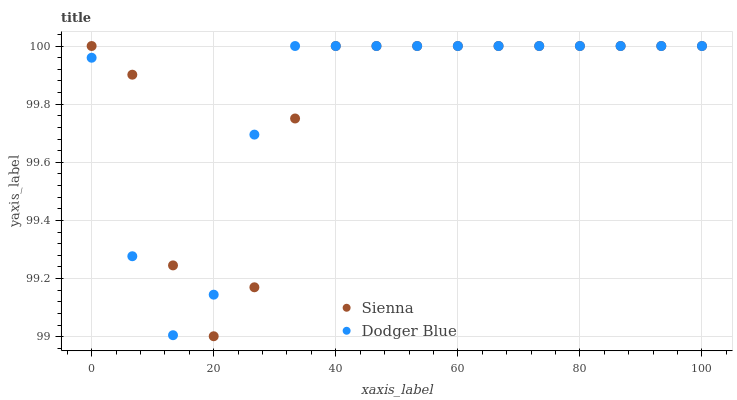Does Sienna have the minimum area under the curve?
Answer yes or no. Yes. Does Dodger Blue have the maximum area under the curve?
Answer yes or no. Yes. Does Dodger Blue have the minimum area under the curve?
Answer yes or no. No. Is Dodger Blue the smoothest?
Answer yes or no. Yes. Is Sienna the roughest?
Answer yes or no. Yes. Is Dodger Blue the roughest?
Answer yes or no. No. Does Sienna have the lowest value?
Answer yes or no. Yes. Does Dodger Blue have the lowest value?
Answer yes or no. No. Does Dodger Blue have the highest value?
Answer yes or no. Yes. Does Sienna intersect Dodger Blue?
Answer yes or no. Yes. Is Sienna less than Dodger Blue?
Answer yes or no. No. Is Sienna greater than Dodger Blue?
Answer yes or no. No. 